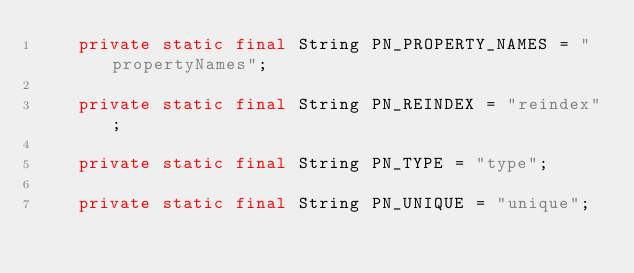<code> <loc_0><loc_0><loc_500><loc_500><_Java_>    private static final String PN_PROPERTY_NAMES = "propertyNames";

    private static final String PN_REINDEX = "reindex";

    private static final String PN_TYPE = "type";

    private static final String PN_UNIQUE = "unique";
</code> 